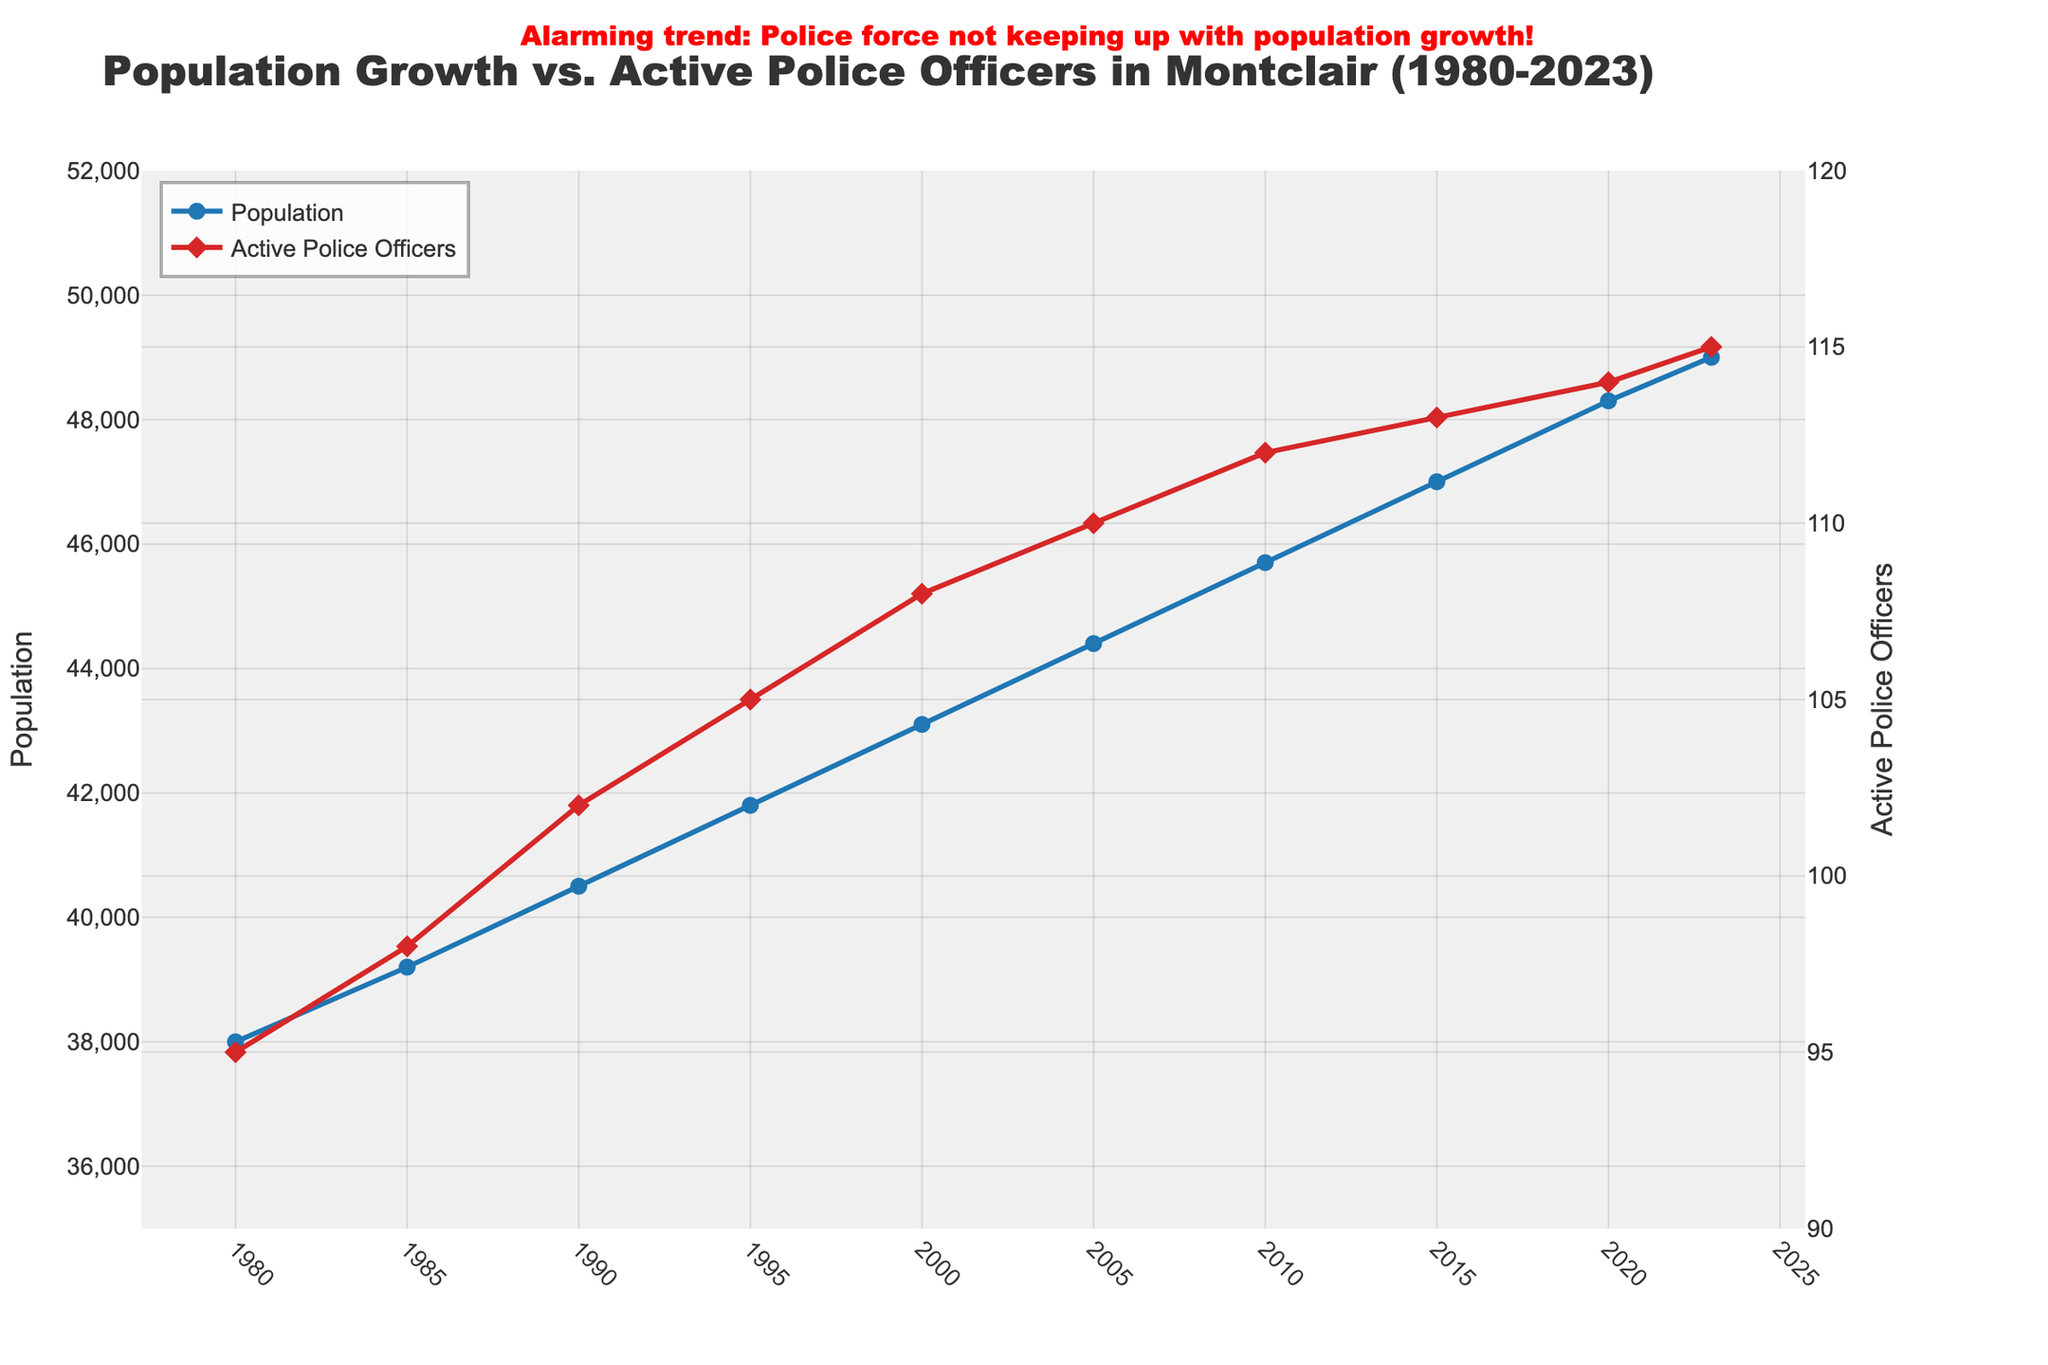Which year had the highest population? To determine this, examine the trend of the blue line representing the population. The highest point on this line indicates the year with the highest population.
Answer: 2023 How many more active police officers were there in 2023 compared to 1980? Inspect the values of active police officers for both years on the red line. Subtract the number of active police officers in 1980 from that in 2023.
Answer: 20 What is the average number of active police officers from 1980 to 2023? Sum up all the values of active police officers from 1980 to 2023 and then divide by the total number of years (10). Calculation: (95+98+102+105+108+110+112+113+114+115) / 10
Answer: 108.2 During which decade did Montclair experience the highest increase in population? Compare the differences in population between consecutive decades by looking at the blue line. Calculate the change in population for each decade and find the largest value.
Answer: 2010-2020 In which year did the number of active police officers first exceed 100? Locate the red line and find the first year where the number of active police officers surpasses 100.
Answer: 1990 What is the midpoint population value for 2023 and 1980? Add the population values for 2023 and 1980, then divide by 2. The calculation is (49000 + 38000) / 2
Answer: 43500 By how many did the number of active police officers increase from 1985 to 2023? Subtract the number of active police officers in 1985 from the number in 2023. The calculation is 115 - 98.
Answer: 17 How does the slope of the population growth line compare between 1980-1990 and 2010-2020? Estimate the steepness of the blue line between the years 1980-1990 and compare it to the steepness between 2010-2020. Steeper slope indicates faster growth.
Answer: Higher in 2010-2020 What is the ratio of the number of active police officers to the population in 2023? Divide the number of active police officers by the population in 2023. Calculation: 115 / 49000
Answer: 0.00235 